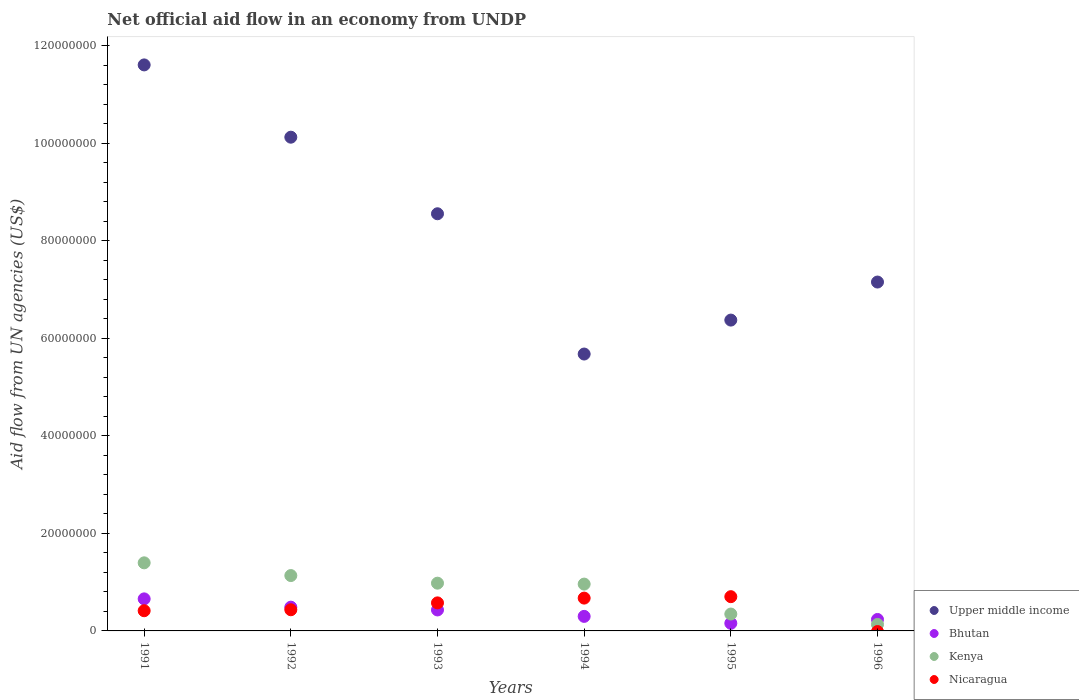Is the number of dotlines equal to the number of legend labels?
Your response must be concise. No. What is the net official aid flow in Upper middle income in 1995?
Keep it short and to the point. 6.37e+07. Across all years, what is the maximum net official aid flow in Upper middle income?
Offer a very short reply. 1.16e+08. Across all years, what is the minimum net official aid flow in Upper middle income?
Offer a terse response. 5.68e+07. In which year was the net official aid flow in Nicaragua maximum?
Keep it short and to the point. 1995. What is the total net official aid flow in Nicaragua in the graph?
Give a very brief answer. 2.80e+07. What is the difference between the net official aid flow in Upper middle income in 1993 and that in 1995?
Keep it short and to the point. 2.18e+07. What is the difference between the net official aid flow in Nicaragua in 1991 and the net official aid flow in Upper middle income in 1996?
Your answer should be very brief. -6.74e+07. What is the average net official aid flow in Kenya per year?
Your response must be concise. 8.25e+06. In the year 1994, what is the difference between the net official aid flow in Kenya and net official aid flow in Upper middle income?
Provide a succinct answer. -4.72e+07. What is the ratio of the net official aid flow in Upper middle income in 1992 to that in 1994?
Make the answer very short. 1.78. Is the net official aid flow in Nicaragua in 1991 less than that in 1993?
Give a very brief answer. Yes. What is the difference between the highest and the second highest net official aid flow in Nicaragua?
Offer a very short reply. 2.90e+05. What is the difference between the highest and the lowest net official aid flow in Kenya?
Ensure brevity in your answer.  1.26e+07. Is it the case that in every year, the sum of the net official aid flow in Nicaragua and net official aid flow in Bhutan  is greater than the sum of net official aid flow in Kenya and net official aid flow in Upper middle income?
Provide a short and direct response. No. Does the net official aid flow in Upper middle income monotonically increase over the years?
Make the answer very short. No. How many dotlines are there?
Provide a succinct answer. 4. What is the difference between two consecutive major ticks on the Y-axis?
Ensure brevity in your answer.  2.00e+07. Does the graph contain grids?
Make the answer very short. No. Where does the legend appear in the graph?
Your answer should be compact. Bottom right. What is the title of the graph?
Your answer should be compact. Net official aid flow in an economy from UNDP. What is the label or title of the X-axis?
Offer a terse response. Years. What is the label or title of the Y-axis?
Keep it short and to the point. Aid flow from UN agencies (US$). What is the Aid flow from UN agencies (US$) of Upper middle income in 1991?
Provide a short and direct response. 1.16e+08. What is the Aid flow from UN agencies (US$) in Bhutan in 1991?
Your answer should be very brief. 6.57e+06. What is the Aid flow from UN agencies (US$) of Kenya in 1991?
Offer a very short reply. 1.40e+07. What is the Aid flow from UN agencies (US$) of Nicaragua in 1991?
Keep it short and to the point. 4.14e+06. What is the Aid flow from UN agencies (US$) of Upper middle income in 1992?
Your answer should be very brief. 1.01e+08. What is the Aid flow from UN agencies (US$) in Bhutan in 1992?
Give a very brief answer. 4.87e+06. What is the Aid flow from UN agencies (US$) in Kenya in 1992?
Give a very brief answer. 1.14e+07. What is the Aid flow from UN agencies (US$) of Nicaragua in 1992?
Ensure brevity in your answer.  4.34e+06. What is the Aid flow from UN agencies (US$) of Upper middle income in 1993?
Provide a succinct answer. 8.55e+07. What is the Aid flow from UN agencies (US$) of Bhutan in 1993?
Your answer should be very brief. 4.30e+06. What is the Aid flow from UN agencies (US$) in Kenya in 1993?
Provide a succinct answer. 9.79e+06. What is the Aid flow from UN agencies (US$) in Nicaragua in 1993?
Your answer should be compact. 5.75e+06. What is the Aid flow from UN agencies (US$) of Upper middle income in 1994?
Offer a very short reply. 5.68e+07. What is the Aid flow from UN agencies (US$) of Bhutan in 1994?
Provide a succinct answer. 2.98e+06. What is the Aid flow from UN agencies (US$) in Kenya in 1994?
Keep it short and to the point. 9.60e+06. What is the Aid flow from UN agencies (US$) of Nicaragua in 1994?
Your answer should be very brief. 6.73e+06. What is the Aid flow from UN agencies (US$) in Upper middle income in 1995?
Your answer should be compact. 6.37e+07. What is the Aid flow from UN agencies (US$) in Bhutan in 1995?
Keep it short and to the point. 1.56e+06. What is the Aid flow from UN agencies (US$) in Kenya in 1995?
Provide a succinct answer. 3.46e+06. What is the Aid flow from UN agencies (US$) of Nicaragua in 1995?
Ensure brevity in your answer.  7.02e+06. What is the Aid flow from UN agencies (US$) in Upper middle income in 1996?
Make the answer very short. 7.15e+07. What is the Aid flow from UN agencies (US$) of Bhutan in 1996?
Offer a very short reply. 2.35e+06. What is the Aid flow from UN agencies (US$) of Kenya in 1996?
Ensure brevity in your answer.  1.33e+06. What is the Aid flow from UN agencies (US$) in Nicaragua in 1996?
Make the answer very short. 0. Across all years, what is the maximum Aid flow from UN agencies (US$) of Upper middle income?
Ensure brevity in your answer.  1.16e+08. Across all years, what is the maximum Aid flow from UN agencies (US$) of Bhutan?
Provide a short and direct response. 6.57e+06. Across all years, what is the maximum Aid flow from UN agencies (US$) in Kenya?
Give a very brief answer. 1.40e+07. Across all years, what is the maximum Aid flow from UN agencies (US$) of Nicaragua?
Give a very brief answer. 7.02e+06. Across all years, what is the minimum Aid flow from UN agencies (US$) in Upper middle income?
Your response must be concise. 5.68e+07. Across all years, what is the minimum Aid flow from UN agencies (US$) in Bhutan?
Your answer should be very brief. 1.56e+06. Across all years, what is the minimum Aid flow from UN agencies (US$) in Kenya?
Offer a terse response. 1.33e+06. Across all years, what is the minimum Aid flow from UN agencies (US$) in Nicaragua?
Make the answer very short. 0. What is the total Aid flow from UN agencies (US$) in Upper middle income in the graph?
Provide a short and direct response. 4.95e+08. What is the total Aid flow from UN agencies (US$) of Bhutan in the graph?
Your answer should be compact. 2.26e+07. What is the total Aid flow from UN agencies (US$) of Kenya in the graph?
Your response must be concise. 4.95e+07. What is the total Aid flow from UN agencies (US$) of Nicaragua in the graph?
Provide a short and direct response. 2.80e+07. What is the difference between the Aid flow from UN agencies (US$) of Upper middle income in 1991 and that in 1992?
Ensure brevity in your answer.  1.48e+07. What is the difference between the Aid flow from UN agencies (US$) in Bhutan in 1991 and that in 1992?
Ensure brevity in your answer.  1.70e+06. What is the difference between the Aid flow from UN agencies (US$) in Kenya in 1991 and that in 1992?
Your response must be concise. 2.61e+06. What is the difference between the Aid flow from UN agencies (US$) of Upper middle income in 1991 and that in 1993?
Provide a short and direct response. 3.05e+07. What is the difference between the Aid flow from UN agencies (US$) in Bhutan in 1991 and that in 1993?
Provide a short and direct response. 2.27e+06. What is the difference between the Aid flow from UN agencies (US$) in Kenya in 1991 and that in 1993?
Offer a terse response. 4.17e+06. What is the difference between the Aid flow from UN agencies (US$) in Nicaragua in 1991 and that in 1993?
Your response must be concise. -1.61e+06. What is the difference between the Aid flow from UN agencies (US$) in Upper middle income in 1991 and that in 1994?
Ensure brevity in your answer.  5.93e+07. What is the difference between the Aid flow from UN agencies (US$) in Bhutan in 1991 and that in 1994?
Your answer should be compact. 3.59e+06. What is the difference between the Aid flow from UN agencies (US$) in Kenya in 1991 and that in 1994?
Provide a short and direct response. 4.36e+06. What is the difference between the Aid flow from UN agencies (US$) of Nicaragua in 1991 and that in 1994?
Keep it short and to the point. -2.59e+06. What is the difference between the Aid flow from UN agencies (US$) of Upper middle income in 1991 and that in 1995?
Your answer should be compact. 5.23e+07. What is the difference between the Aid flow from UN agencies (US$) in Bhutan in 1991 and that in 1995?
Your answer should be compact. 5.01e+06. What is the difference between the Aid flow from UN agencies (US$) of Kenya in 1991 and that in 1995?
Ensure brevity in your answer.  1.05e+07. What is the difference between the Aid flow from UN agencies (US$) in Nicaragua in 1991 and that in 1995?
Ensure brevity in your answer.  -2.88e+06. What is the difference between the Aid flow from UN agencies (US$) of Upper middle income in 1991 and that in 1996?
Your response must be concise. 4.45e+07. What is the difference between the Aid flow from UN agencies (US$) in Bhutan in 1991 and that in 1996?
Keep it short and to the point. 4.22e+06. What is the difference between the Aid flow from UN agencies (US$) in Kenya in 1991 and that in 1996?
Provide a short and direct response. 1.26e+07. What is the difference between the Aid flow from UN agencies (US$) of Upper middle income in 1992 and that in 1993?
Make the answer very short. 1.57e+07. What is the difference between the Aid flow from UN agencies (US$) in Bhutan in 1992 and that in 1993?
Ensure brevity in your answer.  5.70e+05. What is the difference between the Aid flow from UN agencies (US$) in Kenya in 1992 and that in 1993?
Ensure brevity in your answer.  1.56e+06. What is the difference between the Aid flow from UN agencies (US$) of Nicaragua in 1992 and that in 1993?
Your response must be concise. -1.41e+06. What is the difference between the Aid flow from UN agencies (US$) of Upper middle income in 1992 and that in 1994?
Keep it short and to the point. 4.45e+07. What is the difference between the Aid flow from UN agencies (US$) of Bhutan in 1992 and that in 1994?
Give a very brief answer. 1.89e+06. What is the difference between the Aid flow from UN agencies (US$) of Kenya in 1992 and that in 1994?
Provide a short and direct response. 1.75e+06. What is the difference between the Aid flow from UN agencies (US$) of Nicaragua in 1992 and that in 1994?
Offer a very short reply. -2.39e+06. What is the difference between the Aid flow from UN agencies (US$) of Upper middle income in 1992 and that in 1995?
Keep it short and to the point. 3.75e+07. What is the difference between the Aid flow from UN agencies (US$) of Bhutan in 1992 and that in 1995?
Keep it short and to the point. 3.31e+06. What is the difference between the Aid flow from UN agencies (US$) in Kenya in 1992 and that in 1995?
Provide a short and direct response. 7.89e+06. What is the difference between the Aid flow from UN agencies (US$) of Nicaragua in 1992 and that in 1995?
Offer a terse response. -2.68e+06. What is the difference between the Aid flow from UN agencies (US$) in Upper middle income in 1992 and that in 1996?
Keep it short and to the point. 2.97e+07. What is the difference between the Aid flow from UN agencies (US$) of Bhutan in 1992 and that in 1996?
Give a very brief answer. 2.52e+06. What is the difference between the Aid flow from UN agencies (US$) of Kenya in 1992 and that in 1996?
Provide a short and direct response. 1.00e+07. What is the difference between the Aid flow from UN agencies (US$) of Upper middle income in 1993 and that in 1994?
Your response must be concise. 2.88e+07. What is the difference between the Aid flow from UN agencies (US$) in Bhutan in 1993 and that in 1994?
Offer a terse response. 1.32e+06. What is the difference between the Aid flow from UN agencies (US$) in Kenya in 1993 and that in 1994?
Offer a very short reply. 1.90e+05. What is the difference between the Aid flow from UN agencies (US$) in Nicaragua in 1993 and that in 1994?
Offer a very short reply. -9.80e+05. What is the difference between the Aid flow from UN agencies (US$) of Upper middle income in 1993 and that in 1995?
Make the answer very short. 2.18e+07. What is the difference between the Aid flow from UN agencies (US$) of Bhutan in 1993 and that in 1995?
Give a very brief answer. 2.74e+06. What is the difference between the Aid flow from UN agencies (US$) of Kenya in 1993 and that in 1995?
Provide a succinct answer. 6.33e+06. What is the difference between the Aid flow from UN agencies (US$) in Nicaragua in 1993 and that in 1995?
Your answer should be compact. -1.27e+06. What is the difference between the Aid flow from UN agencies (US$) in Upper middle income in 1993 and that in 1996?
Ensure brevity in your answer.  1.40e+07. What is the difference between the Aid flow from UN agencies (US$) of Bhutan in 1993 and that in 1996?
Offer a very short reply. 1.95e+06. What is the difference between the Aid flow from UN agencies (US$) in Kenya in 1993 and that in 1996?
Your answer should be very brief. 8.46e+06. What is the difference between the Aid flow from UN agencies (US$) of Upper middle income in 1994 and that in 1995?
Your response must be concise. -6.96e+06. What is the difference between the Aid flow from UN agencies (US$) of Bhutan in 1994 and that in 1995?
Offer a very short reply. 1.42e+06. What is the difference between the Aid flow from UN agencies (US$) in Kenya in 1994 and that in 1995?
Your answer should be compact. 6.14e+06. What is the difference between the Aid flow from UN agencies (US$) in Upper middle income in 1994 and that in 1996?
Give a very brief answer. -1.48e+07. What is the difference between the Aid flow from UN agencies (US$) in Bhutan in 1994 and that in 1996?
Ensure brevity in your answer.  6.30e+05. What is the difference between the Aid flow from UN agencies (US$) of Kenya in 1994 and that in 1996?
Offer a terse response. 8.27e+06. What is the difference between the Aid flow from UN agencies (US$) in Upper middle income in 1995 and that in 1996?
Keep it short and to the point. -7.80e+06. What is the difference between the Aid flow from UN agencies (US$) in Bhutan in 1995 and that in 1996?
Keep it short and to the point. -7.90e+05. What is the difference between the Aid flow from UN agencies (US$) of Kenya in 1995 and that in 1996?
Give a very brief answer. 2.13e+06. What is the difference between the Aid flow from UN agencies (US$) of Upper middle income in 1991 and the Aid flow from UN agencies (US$) of Bhutan in 1992?
Make the answer very short. 1.11e+08. What is the difference between the Aid flow from UN agencies (US$) in Upper middle income in 1991 and the Aid flow from UN agencies (US$) in Kenya in 1992?
Your response must be concise. 1.05e+08. What is the difference between the Aid flow from UN agencies (US$) of Upper middle income in 1991 and the Aid flow from UN agencies (US$) of Nicaragua in 1992?
Your response must be concise. 1.12e+08. What is the difference between the Aid flow from UN agencies (US$) in Bhutan in 1991 and the Aid flow from UN agencies (US$) in Kenya in 1992?
Ensure brevity in your answer.  -4.78e+06. What is the difference between the Aid flow from UN agencies (US$) in Bhutan in 1991 and the Aid flow from UN agencies (US$) in Nicaragua in 1992?
Give a very brief answer. 2.23e+06. What is the difference between the Aid flow from UN agencies (US$) in Kenya in 1991 and the Aid flow from UN agencies (US$) in Nicaragua in 1992?
Your response must be concise. 9.62e+06. What is the difference between the Aid flow from UN agencies (US$) of Upper middle income in 1991 and the Aid flow from UN agencies (US$) of Bhutan in 1993?
Make the answer very short. 1.12e+08. What is the difference between the Aid flow from UN agencies (US$) of Upper middle income in 1991 and the Aid flow from UN agencies (US$) of Kenya in 1993?
Give a very brief answer. 1.06e+08. What is the difference between the Aid flow from UN agencies (US$) in Upper middle income in 1991 and the Aid flow from UN agencies (US$) in Nicaragua in 1993?
Keep it short and to the point. 1.10e+08. What is the difference between the Aid flow from UN agencies (US$) of Bhutan in 1991 and the Aid flow from UN agencies (US$) of Kenya in 1993?
Provide a succinct answer. -3.22e+06. What is the difference between the Aid flow from UN agencies (US$) in Bhutan in 1991 and the Aid flow from UN agencies (US$) in Nicaragua in 1993?
Offer a very short reply. 8.20e+05. What is the difference between the Aid flow from UN agencies (US$) in Kenya in 1991 and the Aid flow from UN agencies (US$) in Nicaragua in 1993?
Make the answer very short. 8.21e+06. What is the difference between the Aid flow from UN agencies (US$) in Upper middle income in 1991 and the Aid flow from UN agencies (US$) in Bhutan in 1994?
Provide a succinct answer. 1.13e+08. What is the difference between the Aid flow from UN agencies (US$) of Upper middle income in 1991 and the Aid flow from UN agencies (US$) of Kenya in 1994?
Your answer should be very brief. 1.06e+08. What is the difference between the Aid flow from UN agencies (US$) in Upper middle income in 1991 and the Aid flow from UN agencies (US$) in Nicaragua in 1994?
Keep it short and to the point. 1.09e+08. What is the difference between the Aid flow from UN agencies (US$) in Bhutan in 1991 and the Aid flow from UN agencies (US$) in Kenya in 1994?
Ensure brevity in your answer.  -3.03e+06. What is the difference between the Aid flow from UN agencies (US$) in Kenya in 1991 and the Aid flow from UN agencies (US$) in Nicaragua in 1994?
Ensure brevity in your answer.  7.23e+06. What is the difference between the Aid flow from UN agencies (US$) in Upper middle income in 1991 and the Aid flow from UN agencies (US$) in Bhutan in 1995?
Offer a very short reply. 1.14e+08. What is the difference between the Aid flow from UN agencies (US$) of Upper middle income in 1991 and the Aid flow from UN agencies (US$) of Kenya in 1995?
Give a very brief answer. 1.13e+08. What is the difference between the Aid flow from UN agencies (US$) in Upper middle income in 1991 and the Aid flow from UN agencies (US$) in Nicaragua in 1995?
Provide a succinct answer. 1.09e+08. What is the difference between the Aid flow from UN agencies (US$) in Bhutan in 1991 and the Aid flow from UN agencies (US$) in Kenya in 1995?
Your answer should be compact. 3.11e+06. What is the difference between the Aid flow from UN agencies (US$) of Bhutan in 1991 and the Aid flow from UN agencies (US$) of Nicaragua in 1995?
Keep it short and to the point. -4.50e+05. What is the difference between the Aid flow from UN agencies (US$) in Kenya in 1991 and the Aid flow from UN agencies (US$) in Nicaragua in 1995?
Your answer should be very brief. 6.94e+06. What is the difference between the Aid flow from UN agencies (US$) in Upper middle income in 1991 and the Aid flow from UN agencies (US$) in Bhutan in 1996?
Give a very brief answer. 1.14e+08. What is the difference between the Aid flow from UN agencies (US$) in Upper middle income in 1991 and the Aid flow from UN agencies (US$) in Kenya in 1996?
Make the answer very short. 1.15e+08. What is the difference between the Aid flow from UN agencies (US$) of Bhutan in 1991 and the Aid flow from UN agencies (US$) of Kenya in 1996?
Offer a terse response. 5.24e+06. What is the difference between the Aid flow from UN agencies (US$) in Upper middle income in 1992 and the Aid flow from UN agencies (US$) in Bhutan in 1993?
Your answer should be very brief. 9.69e+07. What is the difference between the Aid flow from UN agencies (US$) of Upper middle income in 1992 and the Aid flow from UN agencies (US$) of Kenya in 1993?
Offer a terse response. 9.14e+07. What is the difference between the Aid flow from UN agencies (US$) in Upper middle income in 1992 and the Aid flow from UN agencies (US$) in Nicaragua in 1993?
Provide a short and direct response. 9.55e+07. What is the difference between the Aid flow from UN agencies (US$) in Bhutan in 1992 and the Aid flow from UN agencies (US$) in Kenya in 1993?
Your response must be concise. -4.92e+06. What is the difference between the Aid flow from UN agencies (US$) of Bhutan in 1992 and the Aid flow from UN agencies (US$) of Nicaragua in 1993?
Offer a very short reply. -8.80e+05. What is the difference between the Aid flow from UN agencies (US$) in Kenya in 1992 and the Aid flow from UN agencies (US$) in Nicaragua in 1993?
Keep it short and to the point. 5.60e+06. What is the difference between the Aid flow from UN agencies (US$) in Upper middle income in 1992 and the Aid flow from UN agencies (US$) in Bhutan in 1994?
Keep it short and to the point. 9.82e+07. What is the difference between the Aid flow from UN agencies (US$) in Upper middle income in 1992 and the Aid flow from UN agencies (US$) in Kenya in 1994?
Your response must be concise. 9.16e+07. What is the difference between the Aid flow from UN agencies (US$) of Upper middle income in 1992 and the Aid flow from UN agencies (US$) of Nicaragua in 1994?
Give a very brief answer. 9.45e+07. What is the difference between the Aid flow from UN agencies (US$) of Bhutan in 1992 and the Aid flow from UN agencies (US$) of Kenya in 1994?
Make the answer very short. -4.73e+06. What is the difference between the Aid flow from UN agencies (US$) of Bhutan in 1992 and the Aid flow from UN agencies (US$) of Nicaragua in 1994?
Make the answer very short. -1.86e+06. What is the difference between the Aid flow from UN agencies (US$) of Kenya in 1992 and the Aid flow from UN agencies (US$) of Nicaragua in 1994?
Offer a very short reply. 4.62e+06. What is the difference between the Aid flow from UN agencies (US$) in Upper middle income in 1992 and the Aid flow from UN agencies (US$) in Bhutan in 1995?
Provide a short and direct response. 9.97e+07. What is the difference between the Aid flow from UN agencies (US$) of Upper middle income in 1992 and the Aid flow from UN agencies (US$) of Kenya in 1995?
Provide a succinct answer. 9.78e+07. What is the difference between the Aid flow from UN agencies (US$) of Upper middle income in 1992 and the Aid flow from UN agencies (US$) of Nicaragua in 1995?
Give a very brief answer. 9.42e+07. What is the difference between the Aid flow from UN agencies (US$) of Bhutan in 1992 and the Aid flow from UN agencies (US$) of Kenya in 1995?
Keep it short and to the point. 1.41e+06. What is the difference between the Aid flow from UN agencies (US$) of Bhutan in 1992 and the Aid flow from UN agencies (US$) of Nicaragua in 1995?
Provide a short and direct response. -2.15e+06. What is the difference between the Aid flow from UN agencies (US$) of Kenya in 1992 and the Aid flow from UN agencies (US$) of Nicaragua in 1995?
Offer a terse response. 4.33e+06. What is the difference between the Aid flow from UN agencies (US$) in Upper middle income in 1992 and the Aid flow from UN agencies (US$) in Bhutan in 1996?
Ensure brevity in your answer.  9.89e+07. What is the difference between the Aid flow from UN agencies (US$) in Upper middle income in 1992 and the Aid flow from UN agencies (US$) in Kenya in 1996?
Ensure brevity in your answer.  9.99e+07. What is the difference between the Aid flow from UN agencies (US$) in Bhutan in 1992 and the Aid flow from UN agencies (US$) in Kenya in 1996?
Offer a very short reply. 3.54e+06. What is the difference between the Aid flow from UN agencies (US$) in Upper middle income in 1993 and the Aid flow from UN agencies (US$) in Bhutan in 1994?
Give a very brief answer. 8.26e+07. What is the difference between the Aid flow from UN agencies (US$) of Upper middle income in 1993 and the Aid flow from UN agencies (US$) of Kenya in 1994?
Your response must be concise. 7.59e+07. What is the difference between the Aid flow from UN agencies (US$) of Upper middle income in 1993 and the Aid flow from UN agencies (US$) of Nicaragua in 1994?
Make the answer very short. 7.88e+07. What is the difference between the Aid flow from UN agencies (US$) in Bhutan in 1993 and the Aid flow from UN agencies (US$) in Kenya in 1994?
Offer a very short reply. -5.30e+06. What is the difference between the Aid flow from UN agencies (US$) in Bhutan in 1993 and the Aid flow from UN agencies (US$) in Nicaragua in 1994?
Give a very brief answer. -2.43e+06. What is the difference between the Aid flow from UN agencies (US$) in Kenya in 1993 and the Aid flow from UN agencies (US$) in Nicaragua in 1994?
Your answer should be compact. 3.06e+06. What is the difference between the Aid flow from UN agencies (US$) of Upper middle income in 1993 and the Aid flow from UN agencies (US$) of Bhutan in 1995?
Give a very brief answer. 8.40e+07. What is the difference between the Aid flow from UN agencies (US$) of Upper middle income in 1993 and the Aid flow from UN agencies (US$) of Kenya in 1995?
Your answer should be very brief. 8.21e+07. What is the difference between the Aid flow from UN agencies (US$) of Upper middle income in 1993 and the Aid flow from UN agencies (US$) of Nicaragua in 1995?
Make the answer very short. 7.85e+07. What is the difference between the Aid flow from UN agencies (US$) in Bhutan in 1993 and the Aid flow from UN agencies (US$) in Kenya in 1995?
Make the answer very short. 8.40e+05. What is the difference between the Aid flow from UN agencies (US$) of Bhutan in 1993 and the Aid flow from UN agencies (US$) of Nicaragua in 1995?
Give a very brief answer. -2.72e+06. What is the difference between the Aid flow from UN agencies (US$) of Kenya in 1993 and the Aid flow from UN agencies (US$) of Nicaragua in 1995?
Provide a short and direct response. 2.77e+06. What is the difference between the Aid flow from UN agencies (US$) in Upper middle income in 1993 and the Aid flow from UN agencies (US$) in Bhutan in 1996?
Provide a succinct answer. 8.32e+07. What is the difference between the Aid flow from UN agencies (US$) of Upper middle income in 1993 and the Aid flow from UN agencies (US$) of Kenya in 1996?
Give a very brief answer. 8.42e+07. What is the difference between the Aid flow from UN agencies (US$) in Bhutan in 1993 and the Aid flow from UN agencies (US$) in Kenya in 1996?
Offer a very short reply. 2.97e+06. What is the difference between the Aid flow from UN agencies (US$) in Upper middle income in 1994 and the Aid flow from UN agencies (US$) in Bhutan in 1995?
Offer a very short reply. 5.52e+07. What is the difference between the Aid flow from UN agencies (US$) in Upper middle income in 1994 and the Aid flow from UN agencies (US$) in Kenya in 1995?
Provide a short and direct response. 5.33e+07. What is the difference between the Aid flow from UN agencies (US$) of Upper middle income in 1994 and the Aid flow from UN agencies (US$) of Nicaragua in 1995?
Make the answer very short. 4.98e+07. What is the difference between the Aid flow from UN agencies (US$) in Bhutan in 1994 and the Aid flow from UN agencies (US$) in Kenya in 1995?
Make the answer very short. -4.80e+05. What is the difference between the Aid flow from UN agencies (US$) of Bhutan in 1994 and the Aid flow from UN agencies (US$) of Nicaragua in 1995?
Give a very brief answer. -4.04e+06. What is the difference between the Aid flow from UN agencies (US$) in Kenya in 1994 and the Aid flow from UN agencies (US$) in Nicaragua in 1995?
Provide a succinct answer. 2.58e+06. What is the difference between the Aid flow from UN agencies (US$) of Upper middle income in 1994 and the Aid flow from UN agencies (US$) of Bhutan in 1996?
Provide a succinct answer. 5.44e+07. What is the difference between the Aid flow from UN agencies (US$) of Upper middle income in 1994 and the Aid flow from UN agencies (US$) of Kenya in 1996?
Keep it short and to the point. 5.54e+07. What is the difference between the Aid flow from UN agencies (US$) of Bhutan in 1994 and the Aid flow from UN agencies (US$) of Kenya in 1996?
Keep it short and to the point. 1.65e+06. What is the difference between the Aid flow from UN agencies (US$) in Upper middle income in 1995 and the Aid flow from UN agencies (US$) in Bhutan in 1996?
Ensure brevity in your answer.  6.14e+07. What is the difference between the Aid flow from UN agencies (US$) in Upper middle income in 1995 and the Aid flow from UN agencies (US$) in Kenya in 1996?
Your answer should be compact. 6.24e+07. What is the average Aid flow from UN agencies (US$) in Upper middle income per year?
Your answer should be compact. 8.25e+07. What is the average Aid flow from UN agencies (US$) of Bhutan per year?
Give a very brief answer. 3.77e+06. What is the average Aid flow from UN agencies (US$) in Kenya per year?
Ensure brevity in your answer.  8.25e+06. What is the average Aid flow from UN agencies (US$) in Nicaragua per year?
Your response must be concise. 4.66e+06. In the year 1991, what is the difference between the Aid flow from UN agencies (US$) of Upper middle income and Aid flow from UN agencies (US$) of Bhutan?
Your answer should be compact. 1.09e+08. In the year 1991, what is the difference between the Aid flow from UN agencies (US$) of Upper middle income and Aid flow from UN agencies (US$) of Kenya?
Make the answer very short. 1.02e+08. In the year 1991, what is the difference between the Aid flow from UN agencies (US$) of Upper middle income and Aid flow from UN agencies (US$) of Nicaragua?
Your answer should be very brief. 1.12e+08. In the year 1991, what is the difference between the Aid flow from UN agencies (US$) of Bhutan and Aid flow from UN agencies (US$) of Kenya?
Your answer should be compact. -7.39e+06. In the year 1991, what is the difference between the Aid flow from UN agencies (US$) of Bhutan and Aid flow from UN agencies (US$) of Nicaragua?
Give a very brief answer. 2.43e+06. In the year 1991, what is the difference between the Aid flow from UN agencies (US$) in Kenya and Aid flow from UN agencies (US$) in Nicaragua?
Offer a very short reply. 9.82e+06. In the year 1992, what is the difference between the Aid flow from UN agencies (US$) of Upper middle income and Aid flow from UN agencies (US$) of Bhutan?
Provide a succinct answer. 9.64e+07. In the year 1992, what is the difference between the Aid flow from UN agencies (US$) in Upper middle income and Aid flow from UN agencies (US$) in Kenya?
Provide a succinct answer. 8.99e+07. In the year 1992, what is the difference between the Aid flow from UN agencies (US$) in Upper middle income and Aid flow from UN agencies (US$) in Nicaragua?
Your answer should be very brief. 9.69e+07. In the year 1992, what is the difference between the Aid flow from UN agencies (US$) of Bhutan and Aid flow from UN agencies (US$) of Kenya?
Ensure brevity in your answer.  -6.48e+06. In the year 1992, what is the difference between the Aid flow from UN agencies (US$) in Bhutan and Aid flow from UN agencies (US$) in Nicaragua?
Provide a short and direct response. 5.30e+05. In the year 1992, what is the difference between the Aid flow from UN agencies (US$) in Kenya and Aid flow from UN agencies (US$) in Nicaragua?
Keep it short and to the point. 7.01e+06. In the year 1993, what is the difference between the Aid flow from UN agencies (US$) in Upper middle income and Aid flow from UN agencies (US$) in Bhutan?
Keep it short and to the point. 8.12e+07. In the year 1993, what is the difference between the Aid flow from UN agencies (US$) in Upper middle income and Aid flow from UN agencies (US$) in Kenya?
Your answer should be compact. 7.57e+07. In the year 1993, what is the difference between the Aid flow from UN agencies (US$) of Upper middle income and Aid flow from UN agencies (US$) of Nicaragua?
Your answer should be very brief. 7.98e+07. In the year 1993, what is the difference between the Aid flow from UN agencies (US$) of Bhutan and Aid flow from UN agencies (US$) of Kenya?
Your answer should be compact. -5.49e+06. In the year 1993, what is the difference between the Aid flow from UN agencies (US$) in Bhutan and Aid flow from UN agencies (US$) in Nicaragua?
Keep it short and to the point. -1.45e+06. In the year 1993, what is the difference between the Aid flow from UN agencies (US$) of Kenya and Aid flow from UN agencies (US$) of Nicaragua?
Ensure brevity in your answer.  4.04e+06. In the year 1994, what is the difference between the Aid flow from UN agencies (US$) of Upper middle income and Aid flow from UN agencies (US$) of Bhutan?
Your answer should be compact. 5.38e+07. In the year 1994, what is the difference between the Aid flow from UN agencies (US$) in Upper middle income and Aid flow from UN agencies (US$) in Kenya?
Give a very brief answer. 4.72e+07. In the year 1994, what is the difference between the Aid flow from UN agencies (US$) of Upper middle income and Aid flow from UN agencies (US$) of Nicaragua?
Give a very brief answer. 5.00e+07. In the year 1994, what is the difference between the Aid flow from UN agencies (US$) of Bhutan and Aid flow from UN agencies (US$) of Kenya?
Offer a terse response. -6.62e+06. In the year 1994, what is the difference between the Aid flow from UN agencies (US$) in Bhutan and Aid flow from UN agencies (US$) in Nicaragua?
Make the answer very short. -3.75e+06. In the year 1994, what is the difference between the Aid flow from UN agencies (US$) in Kenya and Aid flow from UN agencies (US$) in Nicaragua?
Provide a short and direct response. 2.87e+06. In the year 1995, what is the difference between the Aid flow from UN agencies (US$) of Upper middle income and Aid flow from UN agencies (US$) of Bhutan?
Ensure brevity in your answer.  6.22e+07. In the year 1995, what is the difference between the Aid flow from UN agencies (US$) in Upper middle income and Aid flow from UN agencies (US$) in Kenya?
Provide a succinct answer. 6.03e+07. In the year 1995, what is the difference between the Aid flow from UN agencies (US$) in Upper middle income and Aid flow from UN agencies (US$) in Nicaragua?
Offer a very short reply. 5.67e+07. In the year 1995, what is the difference between the Aid flow from UN agencies (US$) in Bhutan and Aid flow from UN agencies (US$) in Kenya?
Give a very brief answer. -1.90e+06. In the year 1995, what is the difference between the Aid flow from UN agencies (US$) in Bhutan and Aid flow from UN agencies (US$) in Nicaragua?
Provide a succinct answer. -5.46e+06. In the year 1995, what is the difference between the Aid flow from UN agencies (US$) of Kenya and Aid flow from UN agencies (US$) of Nicaragua?
Provide a short and direct response. -3.56e+06. In the year 1996, what is the difference between the Aid flow from UN agencies (US$) in Upper middle income and Aid flow from UN agencies (US$) in Bhutan?
Offer a terse response. 6.92e+07. In the year 1996, what is the difference between the Aid flow from UN agencies (US$) in Upper middle income and Aid flow from UN agencies (US$) in Kenya?
Ensure brevity in your answer.  7.02e+07. In the year 1996, what is the difference between the Aid flow from UN agencies (US$) in Bhutan and Aid flow from UN agencies (US$) in Kenya?
Give a very brief answer. 1.02e+06. What is the ratio of the Aid flow from UN agencies (US$) of Upper middle income in 1991 to that in 1992?
Keep it short and to the point. 1.15. What is the ratio of the Aid flow from UN agencies (US$) in Bhutan in 1991 to that in 1992?
Ensure brevity in your answer.  1.35. What is the ratio of the Aid flow from UN agencies (US$) in Kenya in 1991 to that in 1992?
Your answer should be compact. 1.23. What is the ratio of the Aid flow from UN agencies (US$) in Nicaragua in 1991 to that in 1992?
Offer a very short reply. 0.95. What is the ratio of the Aid flow from UN agencies (US$) of Upper middle income in 1991 to that in 1993?
Ensure brevity in your answer.  1.36. What is the ratio of the Aid flow from UN agencies (US$) of Bhutan in 1991 to that in 1993?
Provide a short and direct response. 1.53. What is the ratio of the Aid flow from UN agencies (US$) of Kenya in 1991 to that in 1993?
Ensure brevity in your answer.  1.43. What is the ratio of the Aid flow from UN agencies (US$) of Nicaragua in 1991 to that in 1993?
Your answer should be very brief. 0.72. What is the ratio of the Aid flow from UN agencies (US$) of Upper middle income in 1991 to that in 1994?
Give a very brief answer. 2.04. What is the ratio of the Aid flow from UN agencies (US$) of Bhutan in 1991 to that in 1994?
Your answer should be very brief. 2.2. What is the ratio of the Aid flow from UN agencies (US$) in Kenya in 1991 to that in 1994?
Ensure brevity in your answer.  1.45. What is the ratio of the Aid flow from UN agencies (US$) in Nicaragua in 1991 to that in 1994?
Provide a short and direct response. 0.62. What is the ratio of the Aid flow from UN agencies (US$) in Upper middle income in 1991 to that in 1995?
Your answer should be compact. 1.82. What is the ratio of the Aid flow from UN agencies (US$) of Bhutan in 1991 to that in 1995?
Keep it short and to the point. 4.21. What is the ratio of the Aid flow from UN agencies (US$) in Kenya in 1991 to that in 1995?
Offer a terse response. 4.03. What is the ratio of the Aid flow from UN agencies (US$) in Nicaragua in 1991 to that in 1995?
Ensure brevity in your answer.  0.59. What is the ratio of the Aid flow from UN agencies (US$) of Upper middle income in 1991 to that in 1996?
Provide a succinct answer. 1.62. What is the ratio of the Aid flow from UN agencies (US$) of Bhutan in 1991 to that in 1996?
Make the answer very short. 2.8. What is the ratio of the Aid flow from UN agencies (US$) of Kenya in 1991 to that in 1996?
Make the answer very short. 10.5. What is the ratio of the Aid flow from UN agencies (US$) of Upper middle income in 1992 to that in 1993?
Your answer should be compact. 1.18. What is the ratio of the Aid flow from UN agencies (US$) of Bhutan in 1992 to that in 1993?
Offer a terse response. 1.13. What is the ratio of the Aid flow from UN agencies (US$) in Kenya in 1992 to that in 1993?
Keep it short and to the point. 1.16. What is the ratio of the Aid flow from UN agencies (US$) in Nicaragua in 1992 to that in 1993?
Provide a short and direct response. 0.75. What is the ratio of the Aid flow from UN agencies (US$) in Upper middle income in 1992 to that in 1994?
Offer a terse response. 1.78. What is the ratio of the Aid flow from UN agencies (US$) of Bhutan in 1992 to that in 1994?
Offer a very short reply. 1.63. What is the ratio of the Aid flow from UN agencies (US$) in Kenya in 1992 to that in 1994?
Make the answer very short. 1.18. What is the ratio of the Aid flow from UN agencies (US$) of Nicaragua in 1992 to that in 1994?
Provide a short and direct response. 0.64. What is the ratio of the Aid flow from UN agencies (US$) of Upper middle income in 1992 to that in 1995?
Offer a terse response. 1.59. What is the ratio of the Aid flow from UN agencies (US$) in Bhutan in 1992 to that in 1995?
Provide a succinct answer. 3.12. What is the ratio of the Aid flow from UN agencies (US$) in Kenya in 1992 to that in 1995?
Your response must be concise. 3.28. What is the ratio of the Aid flow from UN agencies (US$) in Nicaragua in 1992 to that in 1995?
Your answer should be compact. 0.62. What is the ratio of the Aid flow from UN agencies (US$) in Upper middle income in 1992 to that in 1996?
Offer a very short reply. 1.42. What is the ratio of the Aid flow from UN agencies (US$) of Bhutan in 1992 to that in 1996?
Offer a terse response. 2.07. What is the ratio of the Aid flow from UN agencies (US$) of Kenya in 1992 to that in 1996?
Provide a succinct answer. 8.53. What is the ratio of the Aid flow from UN agencies (US$) in Upper middle income in 1993 to that in 1994?
Provide a short and direct response. 1.51. What is the ratio of the Aid flow from UN agencies (US$) of Bhutan in 1993 to that in 1994?
Offer a terse response. 1.44. What is the ratio of the Aid flow from UN agencies (US$) of Kenya in 1993 to that in 1994?
Give a very brief answer. 1.02. What is the ratio of the Aid flow from UN agencies (US$) in Nicaragua in 1993 to that in 1994?
Your answer should be very brief. 0.85. What is the ratio of the Aid flow from UN agencies (US$) in Upper middle income in 1993 to that in 1995?
Your response must be concise. 1.34. What is the ratio of the Aid flow from UN agencies (US$) of Bhutan in 1993 to that in 1995?
Ensure brevity in your answer.  2.76. What is the ratio of the Aid flow from UN agencies (US$) in Kenya in 1993 to that in 1995?
Keep it short and to the point. 2.83. What is the ratio of the Aid flow from UN agencies (US$) in Nicaragua in 1993 to that in 1995?
Your response must be concise. 0.82. What is the ratio of the Aid flow from UN agencies (US$) in Upper middle income in 1993 to that in 1996?
Your answer should be very brief. 1.2. What is the ratio of the Aid flow from UN agencies (US$) in Bhutan in 1993 to that in 1996?
Make the answer very short. 1.83. What is the ratio of the Aid flow from UN agencies (US$) of Kenya in 1993 to that in 1996?
Your answer should be compact. 7.36. What is the ratio of the Aid flow from UN agencies (US$) in Upper middle income in 1994 to that in 1995?
Offer a very short reply. 0.89. What is the ratio of the Aid flow from UN agencies (US$) of Bhutan in 1994 to that in 1995?
Make the answer very short. 1.91. What is the ratio of the Aid flow from UN agencies (US$) in Kenya in 1994 to that in 1995?
Your response must be concise. 2.77. What is the ratio of the Aid flow from UN agencies (US$) in Nicaragua in 1994 to that in 1995?
Ensure brevity in your answer.  0.96. What is the ratio of the Aid flow from UN agencies (US$) in Upper middle income in 1994 to that in 1996?
Give a very brief answer. 0.79. What is the ratio of the Aid flow from UN agencies (US$) in Bhutan in 1994 to that in 1996?
Provide a short and direct response. 1.27. What is the ratio of the Aid flow from UN agencies (US$) of Kenya in 1994 to that in 1996?
Provide a short and direct response. 7.22. What is the ratio of the Aid flow from UN agencies (US$) of Upper middle income in 1995 to that in 1996?
Give a very brief answer. 0.89. What is the ratio of the Aid flow from UN agencies (US$) of Bhutan in 1995 to that in 1996?
Ensure brevity in your answer.  0.66. What is the ratio of the Aid flow from UN agencies (US$) in Kenya in 1995 to that in 1996?
Your response must be concise. 2.6. What is the difference between the highest and the second highest Aid flow from UN agencies (US$) in Upper middle income?
Provide a short and direct response. 1.48e+07. What is the difference between the highest and the second highest Aid flow from UN agencies (US$) of Bhutan?
Keep it short and to the point. 1.70e+06. What is the difference between the highest and the second highest Aid flow from UN agencies (US$) of Kenya?
Ensure brevity in your answer.  2.61e+06. What is the difference between the highest and the second highest Aid flow from UN agencies (US$) in Nicaragua?
Ensure brevity in your answer.  2.90e+05. What is the difference between the highest and the lowest Aid flow from UN agencies (US$) of Upper middle income?
Your answer should be very brief. 5.93e+07. What is the difference between the highest and the lowest Aid flow from UN agencies (US$) of Bhutan?
Offer a terse response. 5.01e+06. What is the difference between the highest and the lowest Aid flow from UN agencies (US$) in Kenya?
Your answer should be very brief. 1.26e+07. What is the difference between the highest and the lowest Aid flow from UN agencies (US$) of Nicaragua?
Provide a short and direct response. 7.02e+06. 